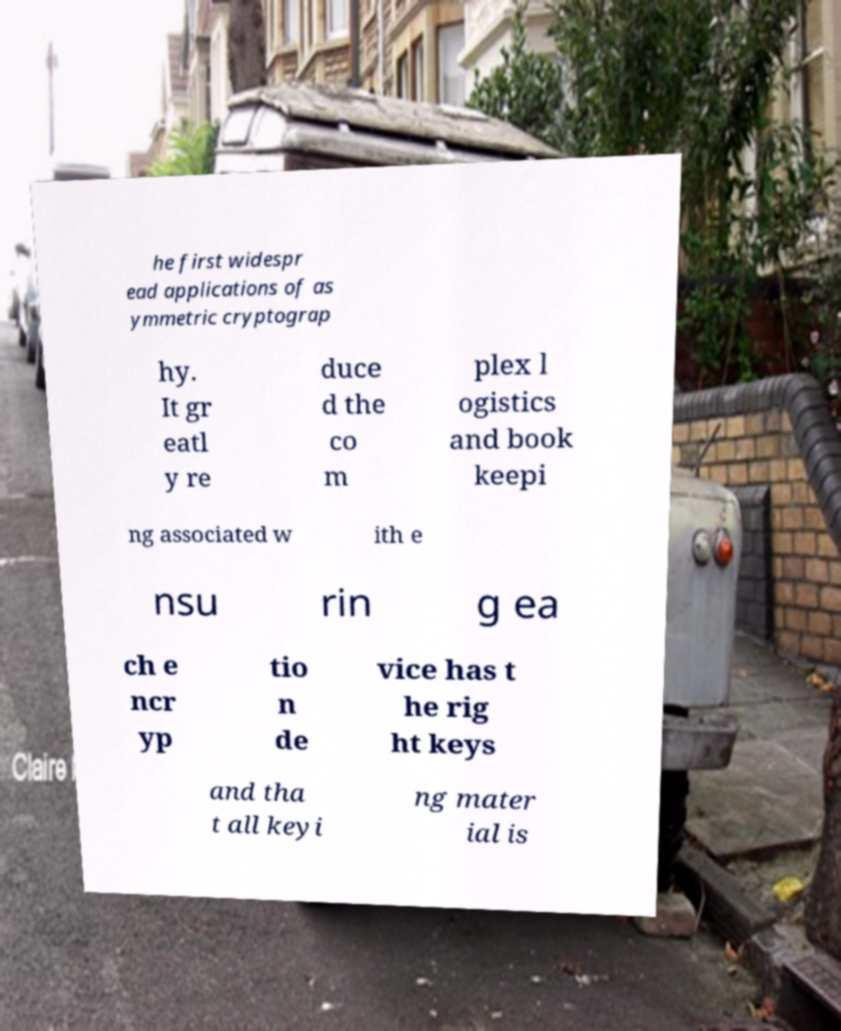Can you read and provide the text displayed in the image?This photo seems to have some interesting text. Can you extract and type it out for me? he first widespr ead applications of as ymmetric cryptograp hy. It gr eatl y re duce d the co m plex l ogistics and book keepi ng associated w ith e nsu rin g ea ch e ncr yp tio n de vice has t he rig ht keys and tha t all keyi ng mater ial is 